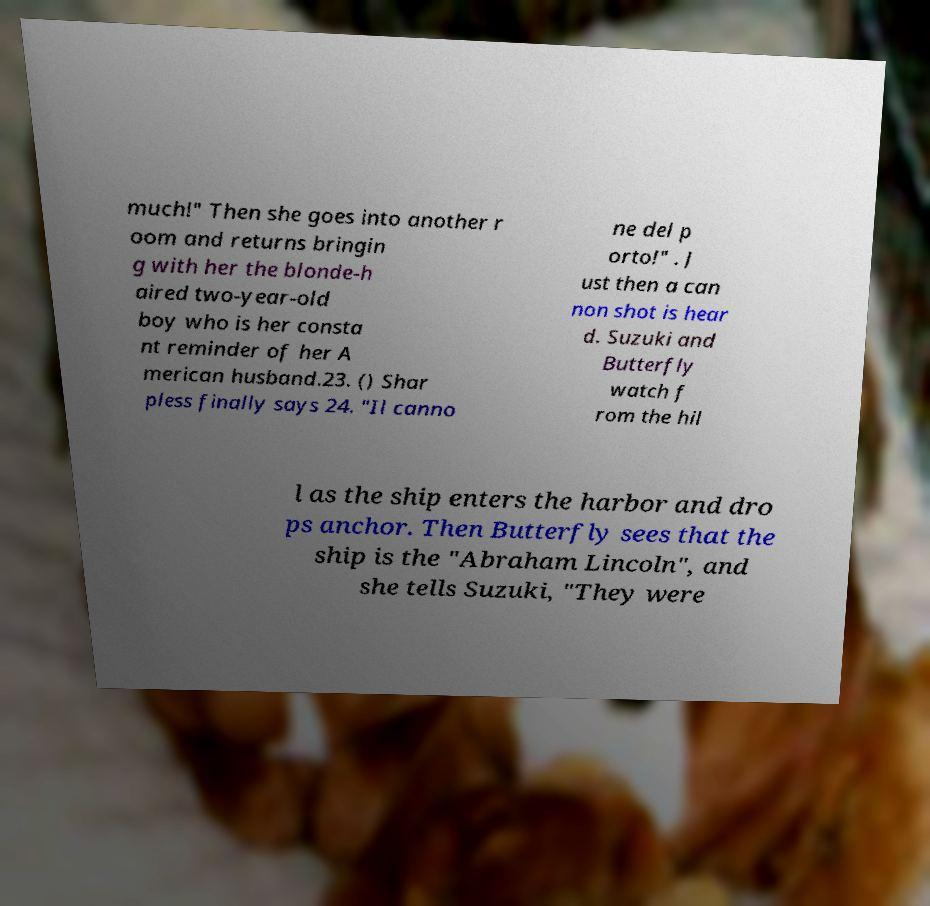Please read and relay the text visible in this image. What does it say? much!" Then she goes into another r oom and returns bringin g with her the blonde-h aired two-year-old boy who is her consta nt reminder of her A merican husband.23. () Shar pless finally says 24. "Il canno ne del p orto!" . J ust then a can non shot is hear d. Suzuki and Butterfly watch f rom the hil l as the ship enters the harbor and dro ps anchor. Then Butterfly sees that the ship is the "Abraham Lincoln", and she tells Suzuki, "They were 